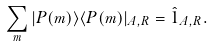<formula> <loc_0><loc_0><loc_500><loc_500>\sum _ { m } | P ( m ) \rangle \langle P ( m ) | _ { A , R } = \hat { 1 } _ { A , R } .</formula> 